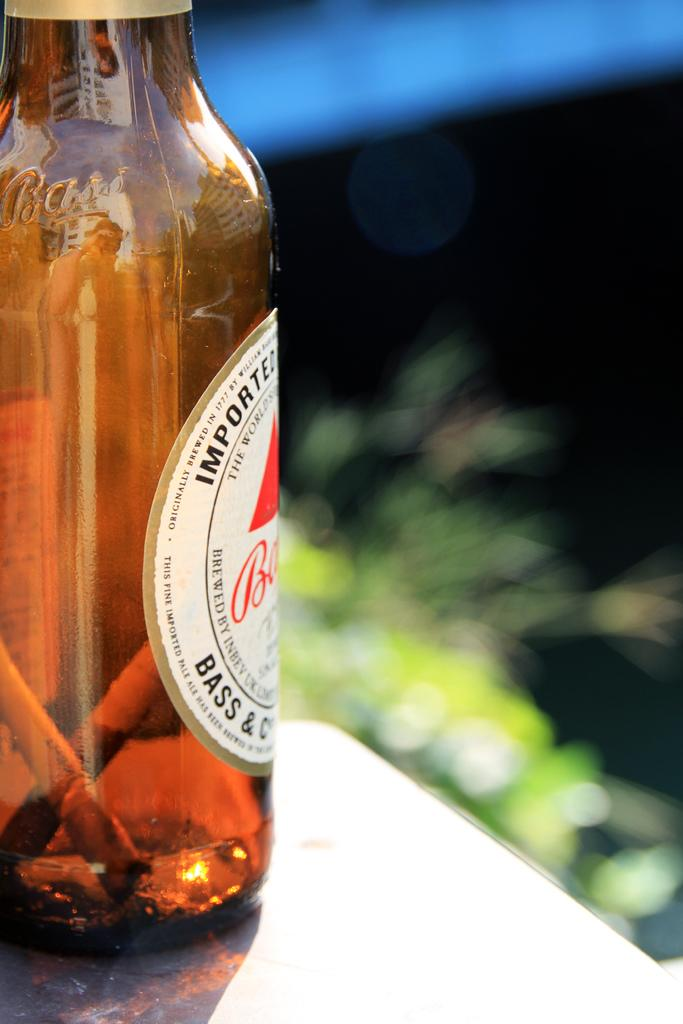<image>
Write a terse but informative summary of the picture. A brown bottle of Bass Ale beer on a counter 